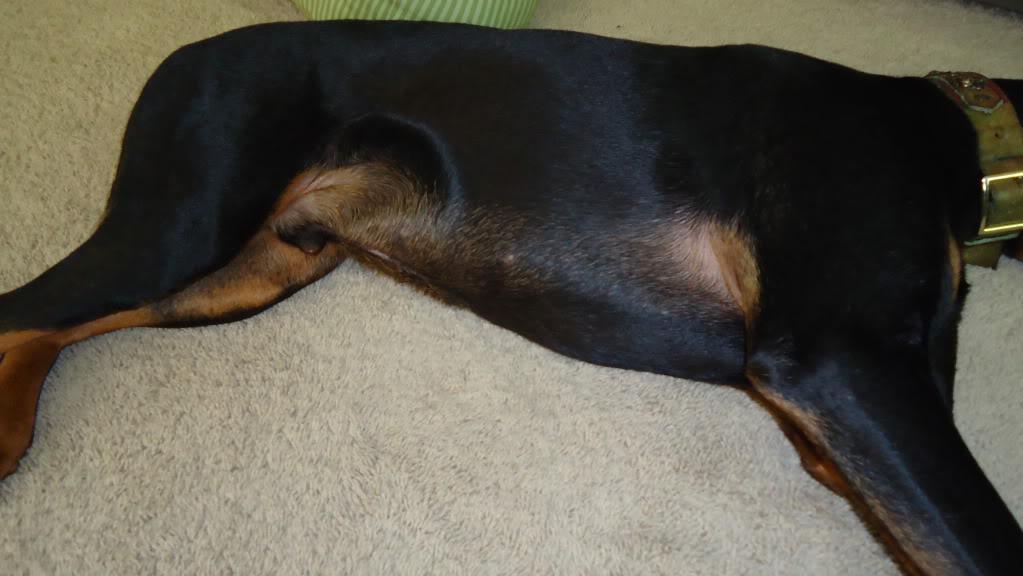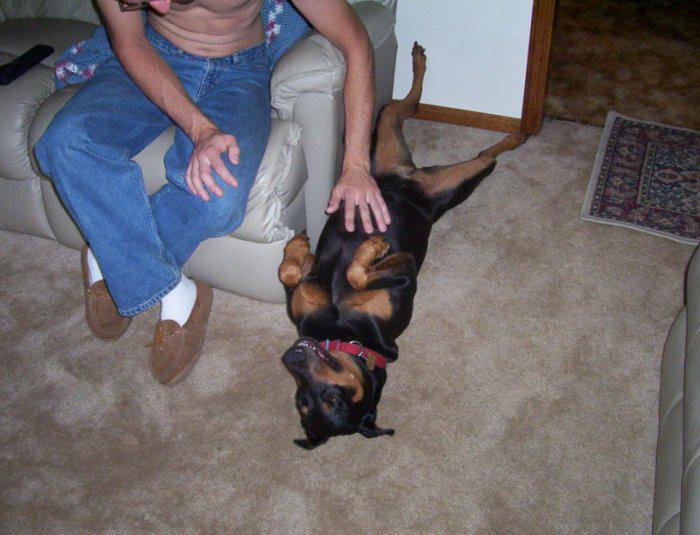The first image is the image on the left, the second image is the image on the right. Analyze the images presented: Is the assertion "A person sitting on upholstered furniture on the left of one image is touching the belly of a dog lying on its back with its front paws bent forward and hind legs extended." valid? Answer yes or no. Yes. The first image is the image on the left, the second image is the image on the right. Examine the images to the left and right. Is the description "The dog in one of the images is getting its belly rubbed." accurate? Answer yes or no. Yes. 